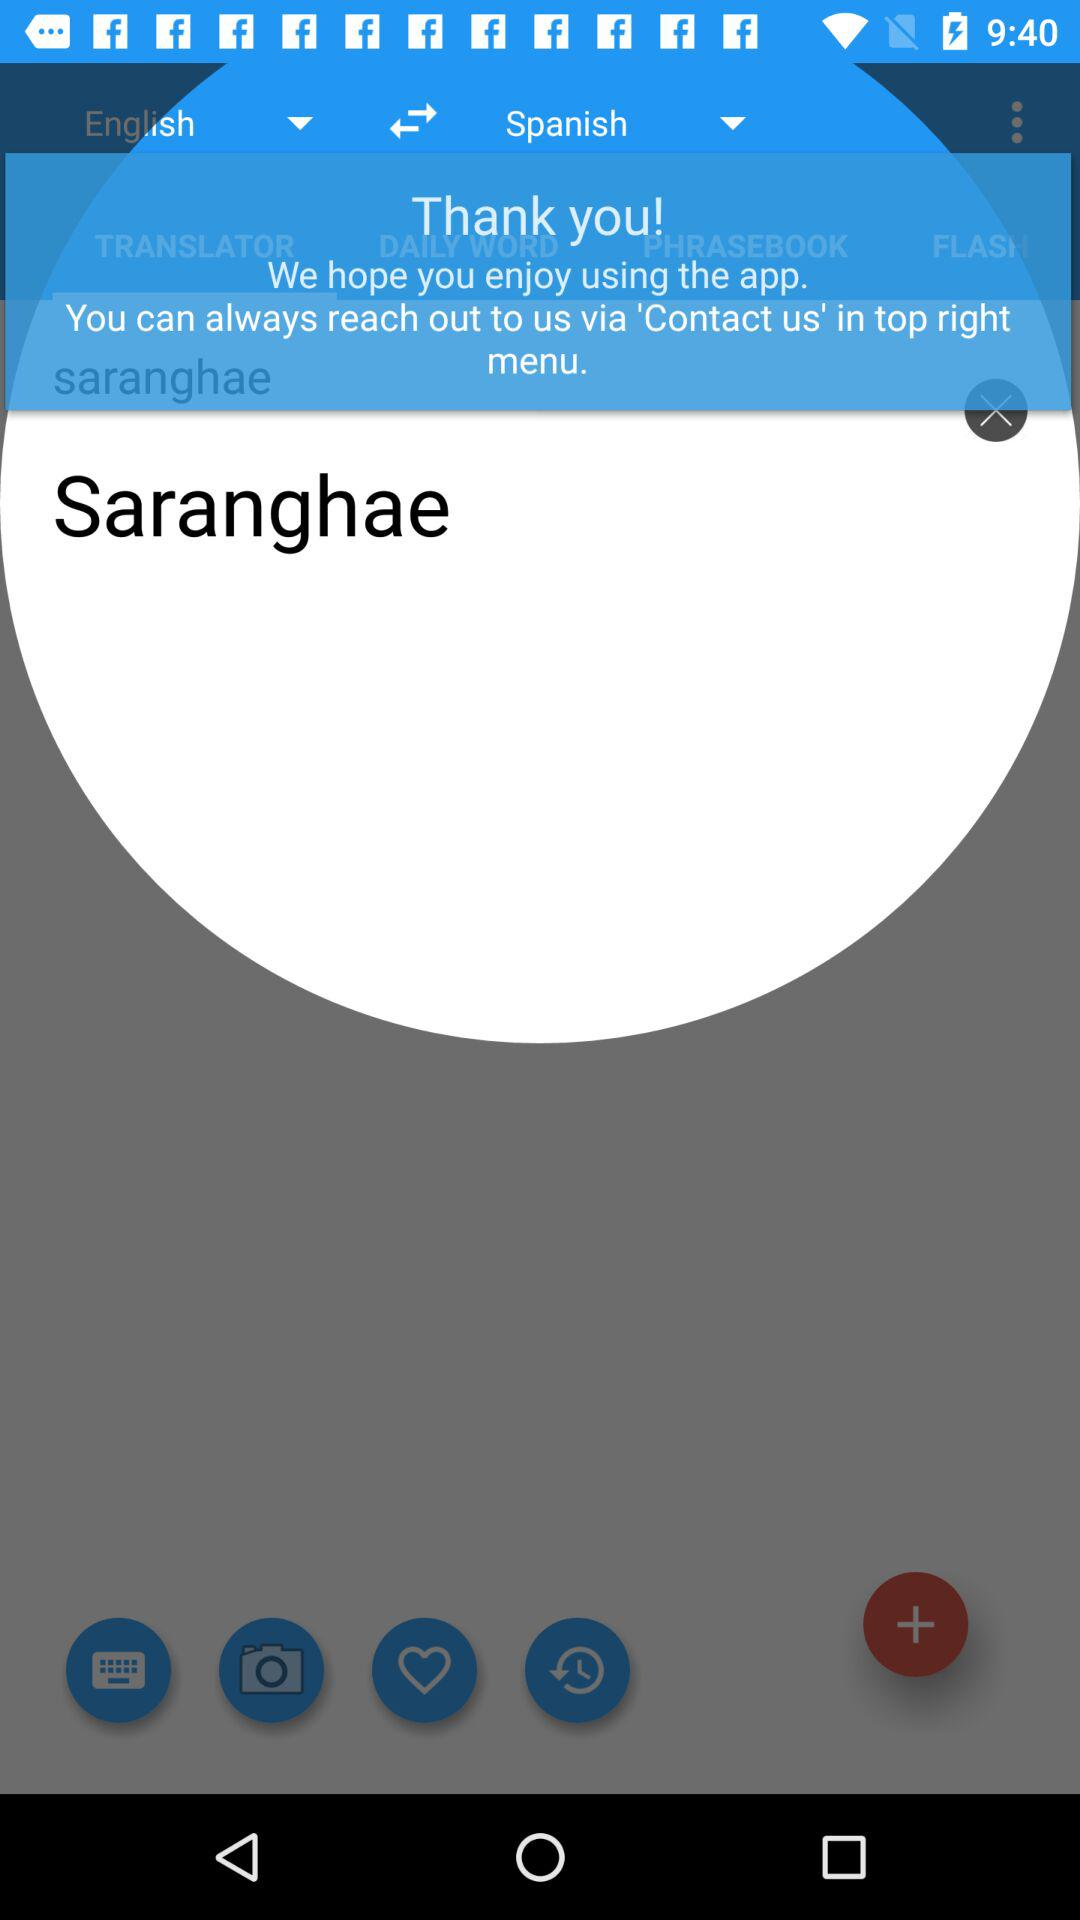How many languages are available in the app?
Answer the question using a single word or phrase. 2 